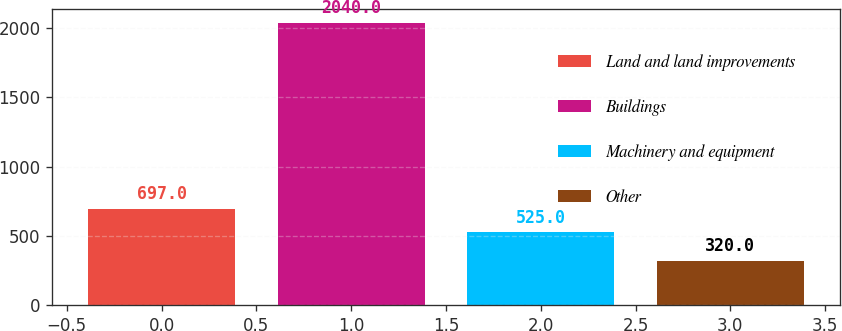Convert chart to OTSL. <chart><loc_0><loc_0><loc_500><loc_500><bar_chart><fcel>Land and land improvements<fcel>Buildings<fcel>Machinery and equipment<fcel>Other<nl><fcel>697<fcel>2040<fcel>525<fcel>320<nl></chart> 